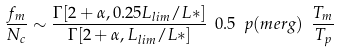<formula> <loc_0><loc_0><loc_500><loc_500>\frac { f _ { m } } { N _ { c } } \sim \frac { \Gamma [ 2 + \alpha , 0 . 2 5 L _ { l i m } / L * ] } { \Gamma [ 2 + \alpha , L _ { l i m } / L * ] } \ 0 . 5 \ p ( m e r g ) \ \frac { T _ { m } } { T _ { p } }</formula> 